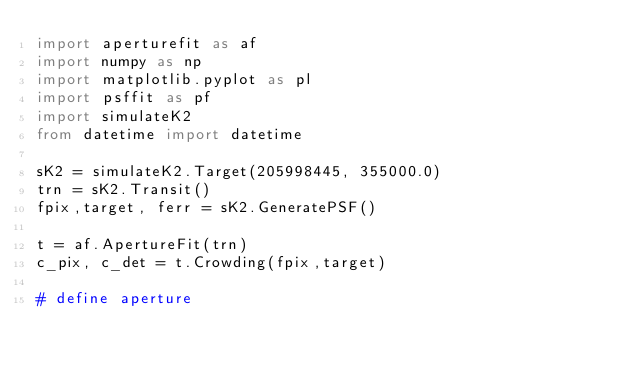<code> <loc_0><loc_0><loc_500><loc_500><_Python_>import aperturefit as af
import numpy as np
import matplotlib.pyplot as pl
import psffit as pf
import simulateK2
from datetime import datetime

sK2 = simulateK2.Target(205998445, 355000.0)
trn = sK2.Transit()
fpix,target, ferr = sK2.GeneratePSF()

t = af.ApertureFit(trn)
c_pix, c_det = t.Crowding(fpix,target)

# define aperture</code> 